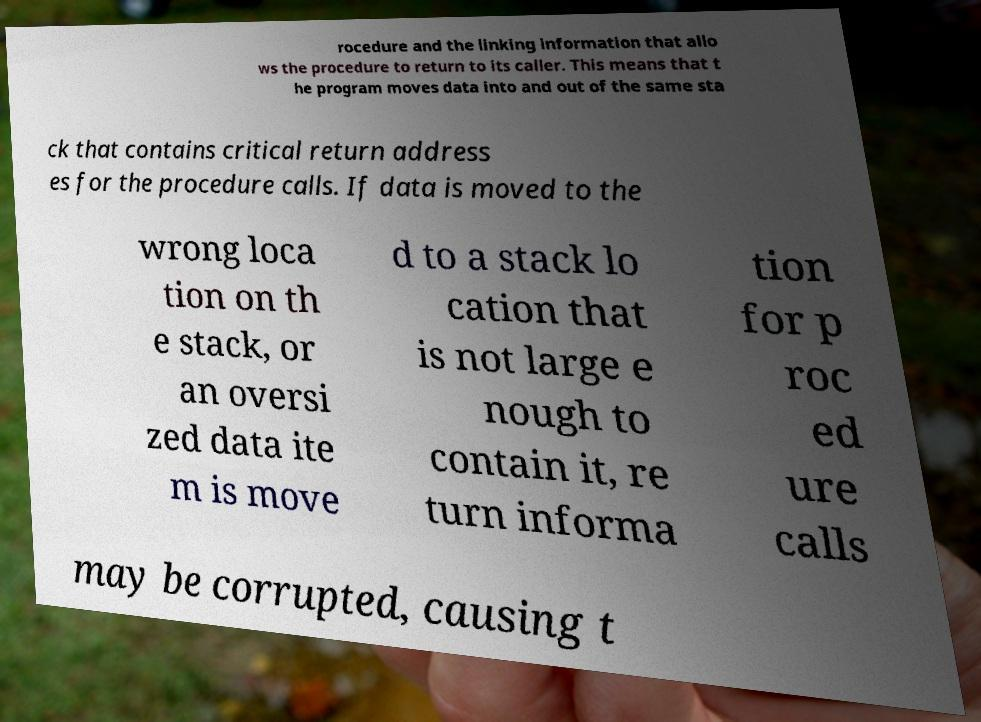What messages or text are displayed in this image? I need them in a readable, typed format. rocedure and the linking information that allo ws the procedure to return to its caller. This means that t he program moves data into and out of the same sta ck that contains critical return address es for the procedure calls. If data is moved to the wrong loca tion on th e stack, or an oversi zed data ite m is move d to a stack lo cation that is not large e nough to contain it, re turn informa tion for p roc ed ure calls may be corrupted, causing t 